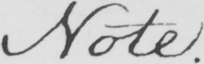What does this handwritten line say? Note . 